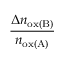Convert formula to latex. <formula><loc_0><loc_0><loc_500><loc_500>\frac { \Delta n _ { o x ( B ) } } { n _ { o x ( A ) } }</formula> 